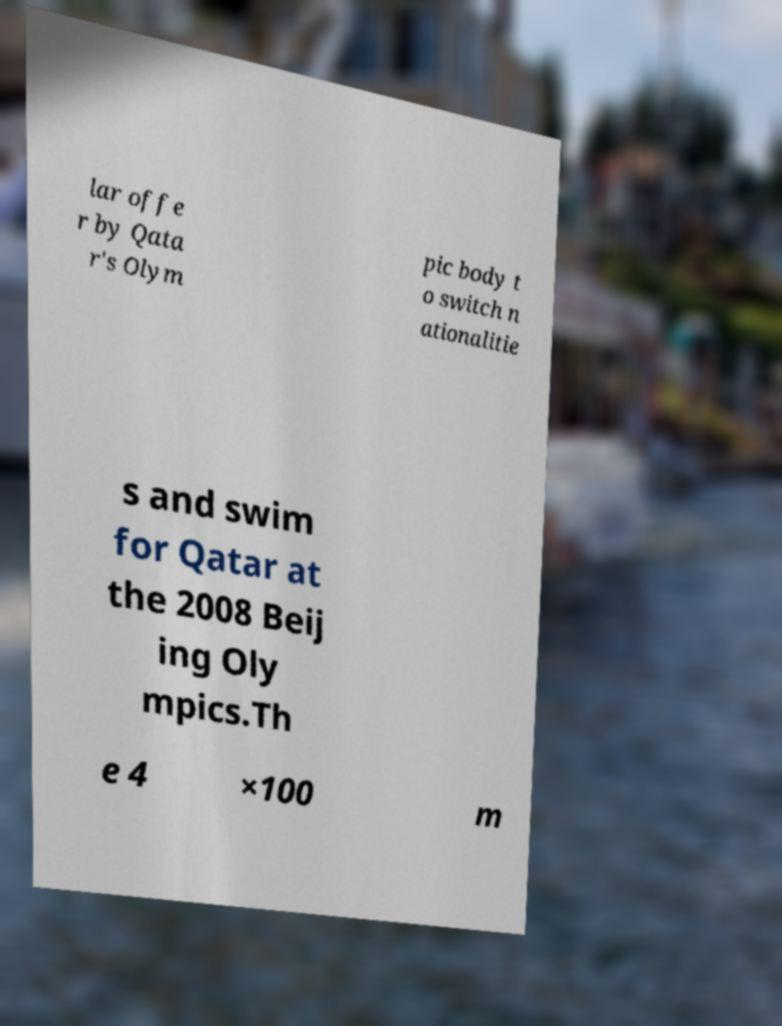What messages or text are displayed in this image? I need them in a readable, typed format. lar offe r by Qata r's Olym pic body t o switch n ationalitie s and swim for Qatar at the 2008 Beij ing Oly mpics.Th e 4 ×100 m 